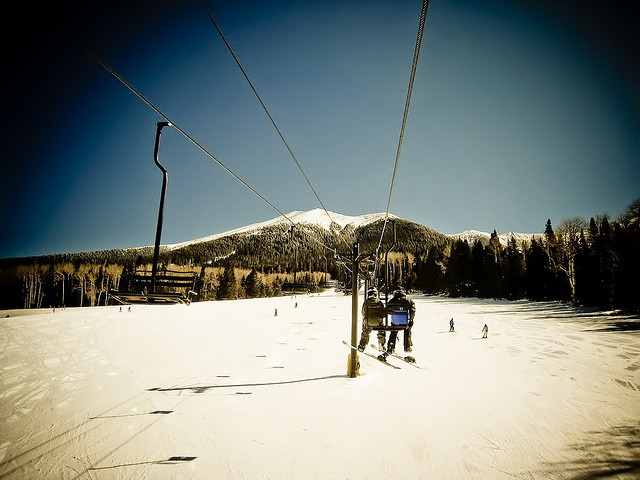Describe the objects in this image and their specific colors. I can see people in black, blue, olive, and ivory tones, people in black, olive, and ivory tones, skis in black, ivory, tan, and beige tones, people in black, ivory, tan, gray, and darkgray tones, and snowboard in black, tan, and ivory tones in this image. 